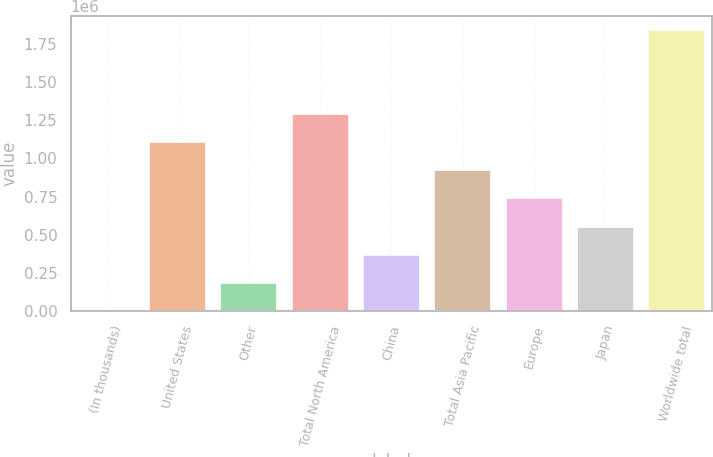Convert chart to OTSL. <chart><loc_0><loc_0><loc_500><loc_500><bar_chart><fcel>(In thousands)<fcel>United States<fcel>Other<fcel>Total North America<fcel>China<fcel>Total Asia Pacific<fcel>Europe<fcel>Japan<fcel>Worldwide total<nl><fcel>2007<fcel>1.10645e+06<fcel>186080<fcel>1.29052e+06<fcel>370153<fcel>922373<fcel>738300<fcel>554227<fcel>1.84274e+06<nl></chart> 